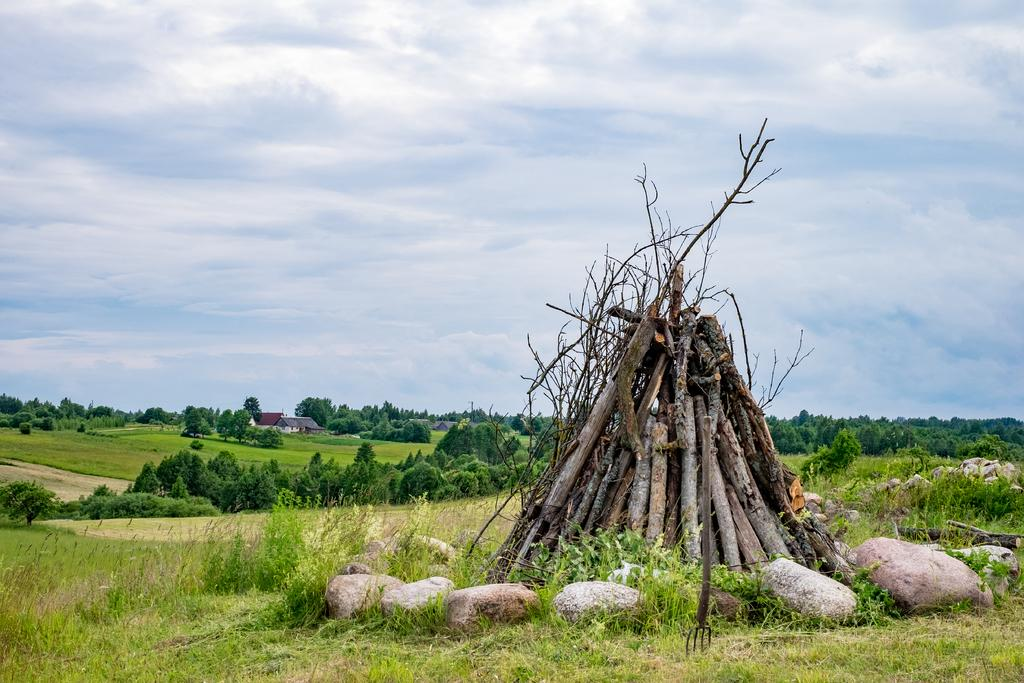What is the main subject of the image? There is a heap of logs in the image. What other objects can be seen in the image? There are rocks visible in the image. What can be seen in the background of the image? There are trees, sheds, and the sky visible in the background of the image. What type of vegetation is at the bottom of the image? There is grass at the bottom of the image. How many pigs are visible in the image? There are no pigs present in the image. What type of tree is growing on the right side of the image? There is no specific tree mentioned or visible in the image; only trees in general are mentioned in the facts. 